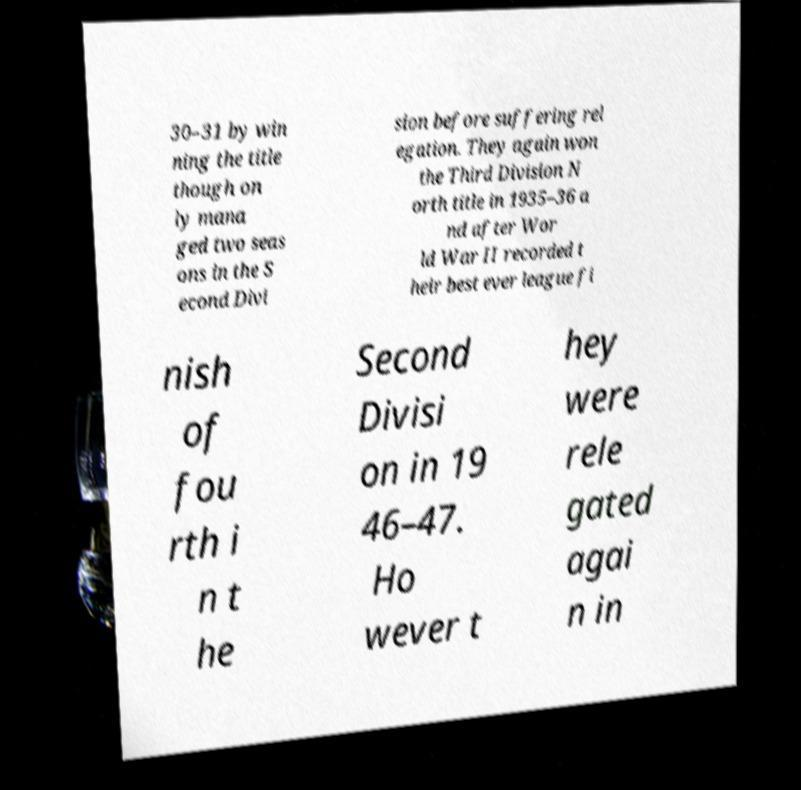What messages or text are displayed in this image? I need them in a readable, typed format. 30–31 by win ning the title though on ly mana ged two seas ons in the S econd Divi sion before suffering rel egation. They again won the Third Division N orth title in 1935–36 a nd after Wor ld War II recorded t heir best ever league fi nish of fou rth i n t he Second Divisi on in 19 46–47. Ho wever t hey were rele gated agai n in 